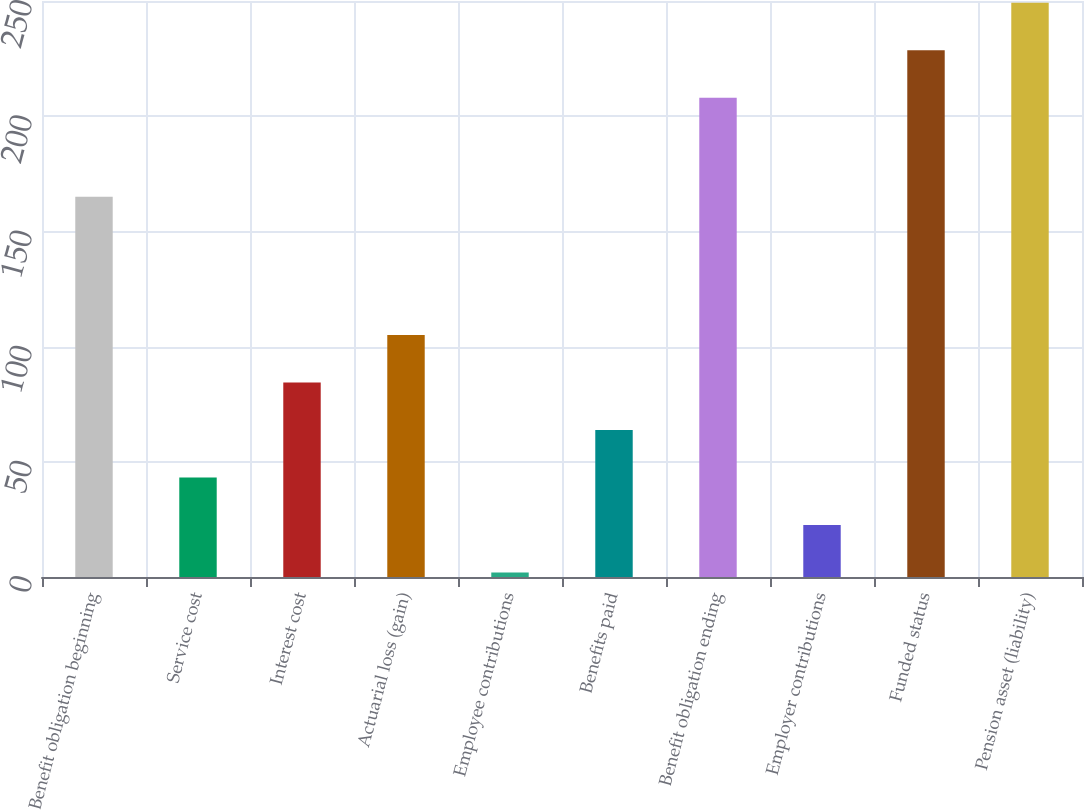Convert chart. <chart><loc_0><loc_0><loc_500><loc_500><bar_chart><fcel>Benefit obligation beginning<fcel>Service cost<fcel>Interest cost<fcel>Actuarial loss (gain)<fcel>Employee contributions<fcel>Benefits paid<fcel>Benefit obligation ending<fcel>Employer contributions<fcel>Funded status<fcel>Pension asset (liability)<nl><fcel>165<fcel>43.2<fcel>84.4<fcel>105<fcel>2<fcel>63.8<fcel>208<fcel>22.6<fcel>228.6<fcel>249.2<nl></chart> 